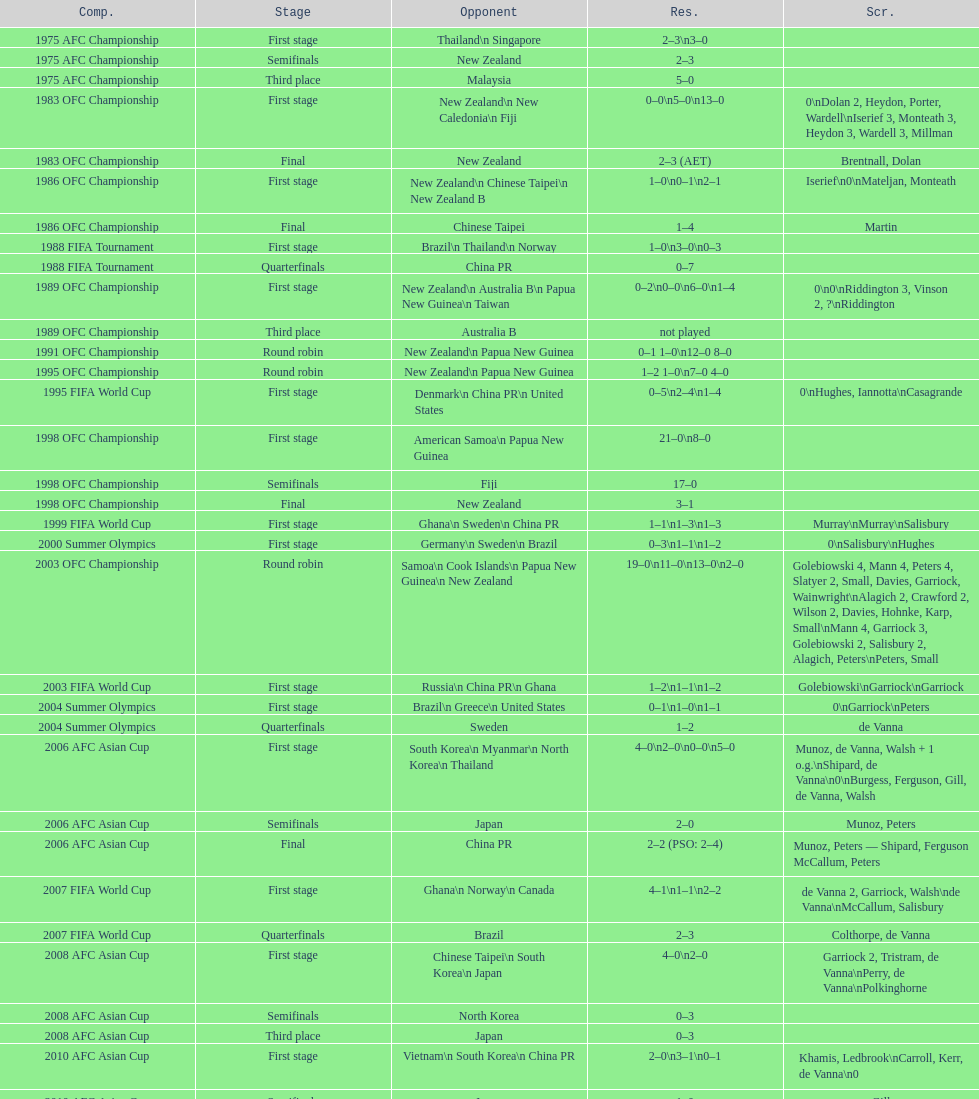Who was the last opponent this team faced in the 2010 afc asian cup? North Korea. 